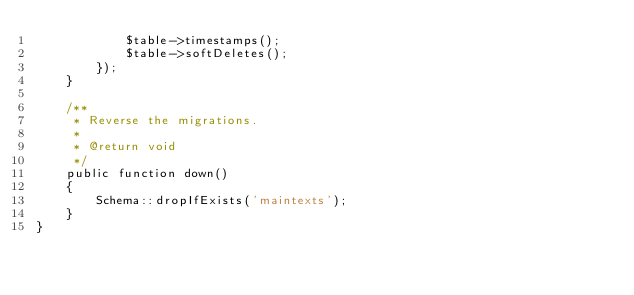<code> <loc_0><loc_0><loc_500><loc_500><_PHP_>            $table->timestamps();
            $table->softDeletes();
        });
    }

    /**
     * Reverse the migrations.
     *
     * @return void
     */
    public function down()
    {
        Schema::dropIfExists('maintexts');
    }
}
</code> 